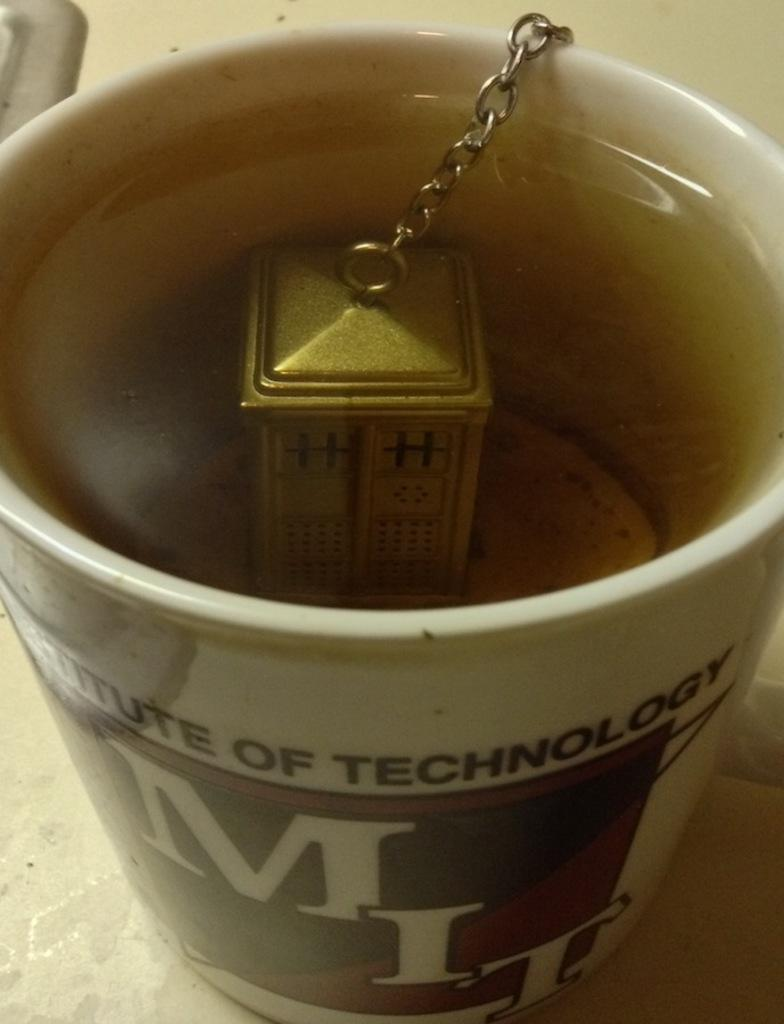Provide a one-sentence caption for the provided image. A tea mug with the name Institute of Technology. 